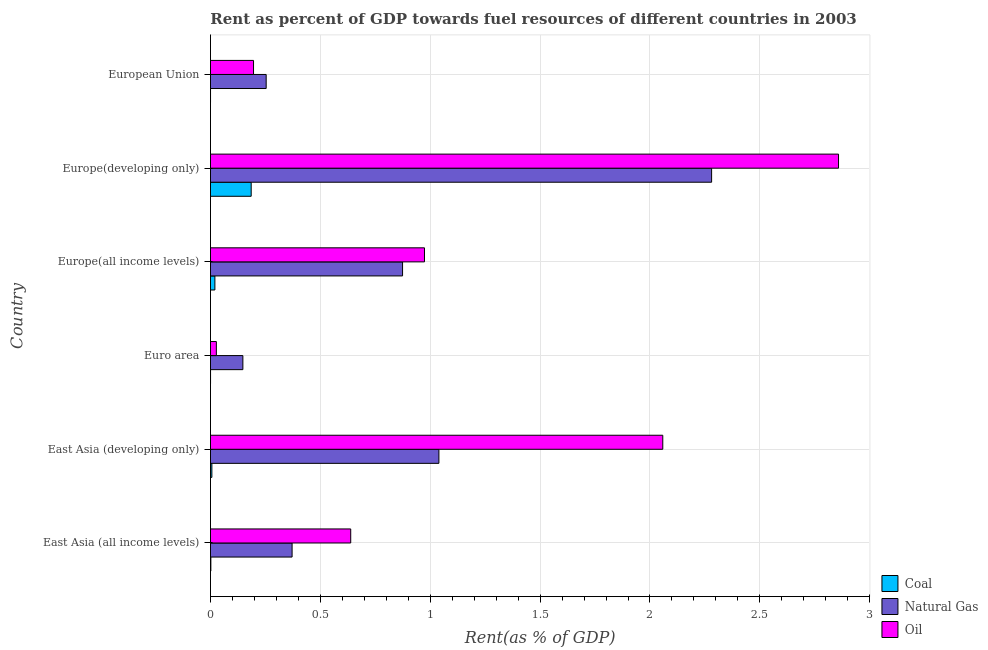How many different coloured bars are there?
Your response must be concise. 3. How many groups of bars are there?
Your answer should be very brief. 6. Are the number of bars per tick equal to the number of legend labels?
Keep it short and to the point. Yes. Are the number of bars on each tick of the Y-axis equal?
Keep it short and to the point. Yes. How many bars are there on the 2nd tick from the top?
Offer a terse response. 3. How many bars are there on the 2nd tick from the bottom?
Your answer should be very brief. 3. What is the rent towards oil in European Union?
Offer a terse response. 0.2. Across all countries, what is the maximum rent towards oil?
Your answer should be very brief. 2.86. Across all countries, what is the minimum rent towards natural gas?
Ensure brevity in your answer.  0.15. In which country was the rent towards oil maximum?
Give a very brief answer. Europe(developing only). What is the total rent towards coal in the graph?
Offer a terse response. 0.21. What is the difference between the rent towards oil in Euro area and that in European Union?
Ensure brevity in your answer.  -0.17. What is the difference between the rent towards oil in Europe(all income levels) and the rent towards natural gas in European Union?
Keep it short and to the point. 0.72. What is the average rent towards natural gas per country?
Your response must be concise. 0.83. What is the difference between the rent towards coal and rent towards natural gas in Europe(all income levels)?
Your answer should be very brief. -0.85. In how many countries, is the rent towards coal greater than 2.5 %?
Provide a succinct answer. 0. What is the ratio of the rent towards oil in East Asia (developing only) to that in Europe(all income levels)?
Make the answer very short. 2.11. Is the rent towards oil in Euro area less than that in Europe(developing only)?
Offer a very short reply. Yes. What is the difference between the highest and the second highest rent towards coal?
Your answer should be very brief. 0.17. What is the difference between the highest and the lowest rent towards natural gas?
Offer a very short reply. 2.13. What does the 2nd bar from the top in Euro area represents?
Keep it short and to the point. Natural Gas. What does the 3rd bar from the bottom in European Union represents?
Make the answer very short. Oil. Is it the case that in every country, the sum of the rent towards coal and rent towards natural gas is greater than the rent towards oil?
Keep it short and to the point. No. How many bars are there?
Keep it short and to the point. 18. How many countries are there in the graph?
Make the answer very short. 6. What is the difference between two consecutive major ticks on the X-axis?
Your response must be concise. 0.5. Does the graph contain any zero values?
Your answer should be compact. No. How many legend labels are there?
Provide a short and direct response. 3. What is the title of the graph?
Offer a terse response. Rent as percent of GDP towards fuel resources of different countries in 2003. Does "Transport equipments" appear as one of the legend labels in the graph?
Offer a terse response. No. What is the label or title of the X-axis?
Keep it short and to the point. Rent(as % of GDP). What is the Rent(as % of GDP) in Coal in East Asia (all income levels)?
Provide a succinct answer. 0. What is the Rent(as % of GDP) of Natural Gas in East Asia (all income levels)?
Offer a terse response. 0.37. What is the Rent(as % of GDP) of Oil in East Asia (all income levels)?
Provide a short and direct response. 0.64. What is the Rent(as % of GDP) of Coal in East Asia (developing only)?
Your response must be concise. 0.01. What is the Rent(as % of GDP) of Natural Gas in East Asia (developing only)?
Offer a terse response. 1.04. What is the Rent(as % of GDP) in Oil in East Asia (developing only)?
Offer a very short reply. 2.06. What is the Rent(as % of GDP) in Coal in Euro area?
Make the answer very short. 0. What is the Rent(as % of GDP) in Natural Gas in Euro area?
Your answer should be very brief. 0.15. What is the Rent(as % of GDP) of Oil in Euro area?
Give a very brief answer. 0.03. What is the Rent(as % of GDP) of Coal in Europe(all income levels)?
Offer a very short reply. 0.02. What is the Rent(as % of GDP) of Natural Gas in Europe(all income levels)?
Your answer should be very brief. 0.87. What is the Rent(as % of GDP) in Oil in Europe(all income levels)?
Offer a terse response. 0.97. What is the Rent(as % of GDP) of Coal in Europe(developing only)?
Provide a succinct answer. 0.19. What is the Rent(as % of GDP) of Natural Gas in Europe(developing only)?
Provide a short and direct response. 2.28. What is the Rent(as % of GDP) of Oil in Europe(developing only)?
Provide a succinct answer. 2.86. What is the Rent(as % of GDP) of Coal in European Union?
Keep it short and to the point. 0. What is the Rent(as % of GDP) of Natural Gas in European Union?
Offer a very short reply. 0.25. What is the Rent(as % of GDP) in Oil in European Union?
Provide a short and direct response. 0.2. Across all countries, what is the maximum Rent(as % of GDP) in Coal?
Provide a succinct answer. 0.19. Across all countries, what is the maximum Rent(as % of GDP) of Natural Gas?
Provide a short and direct response. 2.28. Across all countries, what is the maximum Rent(as % of GDP) of Oil?
Provide a succinct answer. 2.86. Across all countries, what is the minimum Rent(as % of GDP) of Coal?
Make the answer very short. 0. Across all countries, what is the minimum Rent(as % of GDP) of Natural Gas?
Your answer should be compact. 0.15. Across all countries, what is the minimum Rent(as % of GDP) of Oil?
Offer a very short reply. 0.03. What is the total Rent(as % of GDP) in Coal in the graph?
Ensure brevity in your answer.  0.21. What is the total Rent(as % of GDP) of Natural Gas in the graph?
Give a very brief answer. 4.97. What is the total Rent(as % of GDP) of Oil in the graph?
Give a very brief answer. 6.75. What is the difference between the Rent(as % of GDP) of Coal in East Asia (all income levels) and that in East Asia (developing only)?
Provide a short and direct response. -0. What is the difference between the Rent(as % of GDP) of Natural Gas in East Asia (all income levels) and that in East Asia (developing only)?
Ensure brevity in your answer.  -0.67. What is the difference between the Rent(as % of GDP) of Oil in East Asia (all income levels) and that in East Asia (developing only)?
Give a very brief answer. -1.42. What is the difference between the Rent(as % of GDP) of Coal in East Asia (all income levels) and that in Euro area?
Provide a short and direct response. 0. What is the difference between the Rent(as % of GDP) in Natural Gas in East Asia (all income levels) and that in Euro area?
Your response must be concise. 0.22. What is the difference between the Rent(as % of GDP) of Oil in East Asia (all income levels) and that in Euro area?
Provide a succinct answer. 0.61. What is the difference between the Rent(as % of GDP) in Coal in East Asia (all income levels) and that in Europe(all income levels)?
Provide a succinct answer. -0.02. What is the difference between the Rent(as % of GDP) of Natural Gas in East Asia (all income levels) and that in Europe(all income levels)?
Offer a very short reply. -0.5. What is the difference between the Rent(as % of GDP) of Oil in East Asia (all income levels) and that in Europe(all income levels)?
Your response must be concise. -0.34. What is the difference between the Rent(as % of GDP) in Coal in East Asia (all income levels) and that in Europe(developing only)?
Offer a very short reply. -0.18. What is the difference between the Rent(as % of GDP) in Natural Gas in East Asia (all income levels) and that in Europe(developing only)?
Your answer should be compact. -1.91. What is the difference between the Rent(as % of GDP) in Oil in East Asia (all income levels) and that in Europe(developing only)?
Offer a terse response. -2.22. What is the difference between the Rent(as % of GDP) of Coal in East Asia (all income levels) and that in European Union?
Keep it short and to the point. 0. What is the difference between the Rent(as % of GDP) in Natural Gas in East Asia (all income levels) and that in European Union?
Keep it short and to the point. 0.12. What is the difference between the Rent(as % of GDP) in Oil in East Asia (all income levels) and that in European Union?
Provide a succinct answer. 0.44. What is the difference between the Rent(as % of GDP) of Coal in East Asia (developing only) and that in Euro area?
Make the answer very short. 0.01. What is the difference between the Rent(as % of GDP) in Natural Gas in East Asia (developing only) and that in Euro area?
Ensure brevity in your answer.  0.89. What is the difference between the Rent(as % of GDP) in Oil in East Asia (developing only) and that in Euro area?
Ensure brevity in your answer.  2.03. What is the difference between the Rent(as % of GDP) of Coal in East Asia (developing only) and that in Europe(all income levels)?
Provide a short and direct response. -0.01. What is the difference between the Rent(as % of GDP) of Natural Gas in East Asia (developing only) and that in Europe(all income levels)?
Provide a succinct answer. 0.17. What is the difference between the Rent(as % of GDP) of Oil in East Asia (developing only) and that in Europe(all income levels)?
Keep it short and to the point. 1.08. What is the difference between the Rent(as % of GDP) in Coal in East Asia (developing only) and that in Europe(developing only)?
Offer a very short reply. -0.18. What is the difference between the Rent(as % of GDP) of Natural Gas in East Asia (developing only) and that in Europe(developing only)?
Provide a succinct answer. -1.24. What is the difference between the Rent(as % of GDP) of Oil in East Asia (developing only) and that in Europe(developing only)?
Ensure brevity in your answer.  -0.8. What is the difference between the Rent(as % of GDP) of Coal in East Asia (developing only) and that in European Union?
Give a very brief answer. 0.01. What is the difference between the Rent(as % of GDP) in Natural Gas in East Asia (developing only) and that in European Union?
Your answer should be compact. 0.79. What is the difference between the Rent(as % of GDP) in Oil in East Asia (developing only) and that in European Union?
Your response must be concise. 1.86. What is the difference between the Rent(as % of GDP) in Coal in Euro area and that in Europe(all income levels)?
Your response must be concise. -0.02. What is the difference between the Rent(as % of GDP) in Natural Gas in Euro area and that in Europe(all income levels)?
Your response must be concise. -0.73. What is the difference between the Rent(as % of GDP) in Oil in Euro area and that in Europe(all income levels)?
Make the answer very short. -0.95. What is the difference between the Rent(as % of GDP) of Coal in Euro area and that in Europe(developing only)?
Your answer should be very brief. -0.18. What is the difference between the Rent(as % of GDP) in Natural Gas in Euro area and that in Europe(developing only)?
Give a very brief answer. -2.13. What is the difference between the Rent(as % of GDP) in Oil in Euro area and that in Europe(developing only)?
Your answer should be very brief. -2.83. What is the difference between the Rent(as % of GDP) in Natural Gas in Euro area and that in European Union?
Provide a succinct answer. -0.11. What is the difference between the Rent(as % of GDP) in Oil in Euro area and that in European Union?
Offer a very short reply. -0.17. What is the difference between the Rent(as % of GDP) in Coal in Europe(all income levels) and that in Europe(developing only)?
Give a very brief answer. -0.17. What is the difference between the Rent(as % of GDP) in Natural Gas in Europe(all income levels) and that in Europe(developing only)?
Keep it short and to the point. -1.41. What is the difference between the Rent(as % of GDP) in Oil in Europe(all income levels) and that in Europe(developing only)?
Ensure brevity in your answer.  -1.88. What is the difference between the Rent(as % of GDP) in Coal in Europe(all income levels) and that in European Union?
Ensure brevity in your answer.  0.02. What is the difference between the Rent(as % of GDP) in Natural Gas in Europe(all income levels) and that in European Union?
Give a very brief answer. 0.62. What is the difference between the Rent(as % of GDP) in Oil in Europe(all income levels) and that in European Union?
Your answer should be compact. 0.78. What is the difference between the Rent(as % of GDP) in Coal in Europe(developing only) and that in European Union?
Offer a very short reply. 0.18. What is the difference between the Rent(as % of GDP) of Natural Gas in Europe(developing only) and that in European Union?
Ensure brevity in your answer.  2.03. What is the difference between the Rent(as % of GDP) in Oil in Europe(developing only) and that in European Union?
Provide a succinct answer. 2.66. What is the difference between the Rent(as % of GDP) in Coal in East Asia (all income levels) and the Rent(as % of GDP) in Natural Gas in East Asia (developing only)?
Offer a terse response. -1.04. What is the difference between the Rent(as % of GDP) in Coal in East Asia (all income levels) and the Rent(as % of GDP) in Oil in East Asia (developing only)?
Offer a very short reply. -2.06. What is the difference between the Rent(as % of GDP) in Natural Gas in East Asia (all income levels) and the Rent(as % of GDP) in Oil in East Asia (developing only)?
Your answer should be compact. -1.69. What is the difference between the Rent(as % of GDP) of Coal in East Asia (all income levels) and the Rent(as % of GDP) of Natural Gas in Euro area?
Your answer should be very brief. -0.15. What is the difference between the Rent(as % of GDP) in Coal in East Asia (all income levels) and the Rent(as % of GDP) in Oil in Euro area?
Offer a terse response. -0.03. What is the difference between the Rent(as % of GDP) in Natural Gas in East Asia (all income levels) and the Rent(as % of GDP) in Oil in Euro area?
Provide a succinct answer. 0.34. What is the difference between the Rent(as % of GDP) in Coal in East Asia (all income levels) and the Rent(as % of GDP) in Natural Gas in Europe(all income levels)?
Offer a very short reply. -0.87. What is the difference between the Rent(as % of GDP) of Coal in East Asia (all income levels) and the Rent(as % of GDP) of Oil in Europe(all income levels)?
Make the answer very short. -0.97. What is the difference between the Rent(as % of GDP) in Natural Gas in East Asia (all income levels) and the Rent(as % of GDP) in Oil in Europe(all income levels)?
Offer a terse response. -0.6. What is the difference between the Rent(as % of GDP) in Coal in East Asia (all income levels) and the Rent(as % of GDP) in Natural Gas in Europe(developing only)?
Your answer should be compact. -2.28. What is the difference between the Rent(as % of GDP) of Coal in East Asia (all income levels) and the Rent(as % of GDP) of Oil in Europe(developing only)?
Offer a terse response. -2.86. What is the difference between the Rent(as % of GDP) in Natural Gas in East Asia (all income levels) and the Rent(as % of GDP) in Oil in Europe(developing only)?
Offer a very short reply. -2.49. What is the difference between the Rent(as % of GDP) of Coal in East Asia (all income levels) and the Rent(as % of GDP) of Natural Gas in European Union?
Offer a very short reply. -0.25. What is the difference between the Rent(as % of GDP) of Coal in East Asia (all income levels) and the Rent(as % of GDP) of Oil in European Union?
Your answer should be very brief. -0.19. What is the difference between the Rent(as % of GDP) in Natural Gas in East Asia (all income levels) and the Rent(as % of GDP) in Oil in European Union?
Make the answer very short. 0.18. What is the difference between the Rent(as % of GDP) in Coal in East Asia (developing only) and the Rent(as % of GDP) in Natural Gas in Euro area?
Offer a terse response. -0.14. What is the difference between the Rent(as % of GDP) in Coal in East Asia (developing only) and the Rent(as % of GDP) in Oil in Euro area?
Your answer should be compact. -0.02. What is the difference between the Rent(as % of GDP) of Natural Gas in East Asia (developing only) and the Rent(as % of GDP) of Oil in Euro area?
Offer a terse response. 1.01. What is the difference between the Rent(as % of GDP) of Coal in East Asia (developing only) and the Rent(as % of GDP) of Natural Gas in Europe(all income levels)?
Provide a succinct answer. -0.87. What is the difference between the Rent(as % of GDP) of Coal in East Asia (developing only) and the Rent(as % of GDP) of Oil in Europe(all income levels)?
Provide a succinct answer. -0.97. What is the difference between the Rent(as % of GDP) of Natural Gas in East Asia (developing only) and the Rent(as % of GDP) of Oil in Europe(all income levels)?
Offer a terse response. 0.07. What is the difference between the Rent(as % of GDP) in Coal in East Asia (developing only) and the Rent(as % of GDP) in Natural Gas in Europe(developing only)?
Make the answer very short. -2.27. What is the difference between the Rent(as % of GDP) of Coal in East Asia (developing only) and the Rent(as % of GDP) of Oil in Europe(developing only)?
Your response must be concise. -2.85. What is the difference between the Rent(as % of GDP) in Natural Gas in East Asia (developing only) and the Rent(as % of GDP) in Oil in Europe(developing only)?
Provide a short and direct response. -1.82. What is the difference between the Rent(as % of GDP) in Coal in East Asia (developing only) and the Rent(as % of GDP) in Natural Gas in European Union?
Provide a succinct answer. -0.25. What is the difference between the Rent(as % of GDP) of Coal in East Asia (developing only) and the Rent(as % of GDP) of Oil in European Union?
Provide a short and direct response. -0.19. What is the difference between the Rent(as % of GDP) of Natural Gas in East Asia (developing only) and the Rent(as % of GDP) of Oil in European Union?
Make the answer very short. 0.84. What is the difference between the Rent(as % of GDP) in Coal in Euro area and the Rent(as % of GDP) in Natural Gas in Europe(all income levels)?
Provide a succinct answer. -0.87. What is the difference between the Rent(as % of GDP) in Coal in Euro area and the Rent(as % of GDP) in Oil in Europe(all income levels)?
Offer a terse response. -0.97. What is the difference between the Rent(as % of GDP) in Natural Gas in Euro area and the Rent(as % of GDP) in Oil in Europe(all income levels)?
Offer a very short reply. -0.83. What is the difference between the Rent(as % of GDP) of Coal in Euro area and the Rent(as % of GDP) of Natural Gas in Europe(developing only)?
Provide a short and direct response. -2.28. What is the difference between the Rent(as % of GDP) of Coal in Euro area and the Rent(as % of GDP) of Oil in Europe(developing only)?
Your answer should be compact. -2.86. What is the difference between the Rent(as % of GDP) of Natural Gas in Euro area and the Rent(as % of GDP) of Oil in Europe(developing only)?
Provide a short and direct response. -2.71. What is the difference between the Rent(as % of GDP) in Coal in Euro area and the Rent(as % of GDP) in Natural Gas in European Union?
Your response must be concise. -0.25. What is the difference between the Rent(as % of GDP) of Coal in Euro area and the Rent(as % of GDP) of Oil in European Union?
Ensure brevity in your answer.  -0.2. What is the difference between the Rent(as % of GDP) of Natural Gas in Euro area and the Rent(as % of GDP) of Oil in European Union?
Offer a terse response. -0.05. What is the difference between the Rent(as % of GDP) in Coal in Europe(all income levels) and the Rent(as % of GDP) in Natural Gas in Europe(developing only)?
Give a very brief answer. -2.26. What is the difference between the Rent(as % of GDP) in Coal in Europe(all income levels) and the Rent(as % of GDP) in Oil in Europe(developing only)?
Provide a succinct answer. -2.84. What is the difference between the Rent(as % of GDP) of Natural Gas in Europe(all income levels) and the Rent(as % of GDP) of Oil in Europe(developing only)?
Your response must be concise. -1.98. What is the difference between the Rent(as % of GDP) of Coal in Europe(all income levels) and the Rent(as % of GDP) of Natural Gas in European Union?
Your response must be concise. -0.23. What is the difference between the Rent(as % of GDP) in Coal in Europe(all income levels) and the Rent(as % of GDP) in Oil in European Union?
Keep it short and to the point. -0.18. What is the difference between the Rent(as % of GDP) of Natural Gas in Europe(all income levels) and the Rent(as % of GDP) of Oil in European Union?
Your response must be concise. 0.68. What is the difference between the Rent(as % of GDP) in Coal in Europe(developing only) and the Rent(as % of GDP) in Natural Gas in European Union?
Keep it short and to the point. -0.07. What is the difference between the Rent(as % of GDP) in Coal in Europe(developing only) and the Rent(as % of GDP) in Oil in European Union?
Your answer should be very brief. -0.01. What is the difference between the Rent(as % of GDP) in Natural Gas in Europe(developing only) and the Rent(as % of GDP) in Oil in European Union?
Your response must be concise. 2.08. What is the average Rent(as % of GDP) in Coal per country?
Give a very brief answer. 0.04. What is the average Rent(as % of GDP) of Natural Gas per country?
Provide a succinct answer. 0.83. What is the average Rent(as % of GDP) in Oil per country?
Make the answer very short. 1.13. What is the difference between the Rent(as % of GDP) of Coal and Rent(as % of GDP) of Natural Gas in East Asia (all income levels)?
Your answer should be compact. -0.37. What is the difference between the Rent(as % of GDP) of Coal and Rent(as % of GDP) of Oil in East Asia (all income levels)?
Give a very brief answer. -0.64. What is the difference between the Rent(as % of GDP) in Natural Gas and Rent(as % of GDP) in Oil in East Asia (all income levels)?
Provide a short and direct response. -0.27. What is the difference between the Rent(as % of GDP) in Coal and Rent(as % of GDP) in Natural Gas in East Asia (developing only)?
Your answer should be very brief. -1.03. What is the difference between the Rent(as % of GDP) of Coal and Rent(as % of GDP) of Oil in East Asia (developing only)?
Offer a very short reply. -2.05. What is the difference between the Rent(as % of GDP) in Natural Gas and Rent(as % of GDP) in Oil in East Asia (developing only)?
Make the answer very short. -1.02. What is the difference between the Rent(as % of GDP) in Coal and Rent(as % of GDP) in Natural Gas in Euro area?
Make the answer very short. -0.15. What is the difference between the Rent(as % of GDP) in Coal and Rent(as % of GDP) in Oil in Euro area?
Make the answer very short. -0.03. What is the difference between the Rent(as % of GDP) of Natural Gas and Rent(as % of GDP) of Oil in Euro area?
Your answer should be very brief. 0.12. What is the difference between the Rent(as % of GDP) in Coal and Rent(as % of GDP) in Natural Gas in Europe(all income levels)?
Give a very brief answer. -0.85. What is the difference between the Rent(as % of GDP) of Coal and Rent(as % of GDP) of Oil in Europe(all income levels)?
Make the answer very short. -0.95. What is the difference between the Rent(as % of GDP) of Natural Gas and Rent(as % of GDP) of Oil in Europe(all income levels)?
Make the answer very short. -0.1. What is the difference between the Rent(as % of GDP) of Coal and Rent(as % of GDP) of Natural Gas in Europe(developing only)?
Offer a terse response. -2.1. What is the difference between the Rent(as % of GDP) in Coal and Rent(as % of GDP) in Oil in Europe(developing only)?
Ensure brevity in your answer.  -2.67. What is the difference between the Rent(as % of GDP) of Natural Gas and Rent(as % of GDP) of Oil in Europe(developing only)?
Keep it short and to the point. -0.58. What is the difference between the Rent(as % of GDP) of Coal and Rent(as % of GDP) of Natural Gas in European Union?
Your answer should be compact. -0.25. What is the difference between the Rent(as % of GDP) in Coal and Rent(as % of GDP) in Oil in European Union?
Make the answer very short. -0.2. What is the difference between the Rent(as % of GDP) of Natural Gas and Rent(as % of GDP) of Oil in European Union?
Your answer should be very brief. 0.06. What is the ratio of the Rent(as % of GDP) in Coal in East Asia (all income levels) to that in East Asia (developing only)?
Your answer should be very brief. 0.27. What is the ratio of the Rent(as % of GDP) in Natural Gas in East Asia (all income levels) to that in East Asia (developing only)?
Your answer should be very brief. 0.36. What is the ratio of the Rent(as % of GDP) of Oil in East Asia (all income levels) to that in East Asia (developing only)?
Offer a terse response. 0.31. What is the ratio of the Rent(as % of GDP) in Coal in East Asia (all income levels) to that in Euro area?
Ensure brevity in your answer.  4.9. What is the ratio of the Rent(as % of GDP) of Natural Gas in East Asia (all income levels) to that in Euro area?
Keep it short and to the point. 2.52. What is the ratio of the Rent(as % of GDP) in Oil in East Asia (all income levels) to that in Euro area?
Provide a succinct answer. 23.8. What is the ratio of the Rent(as % of GDP) in Coal in East Asia (all income levels) to that in Europe(all income levels)?
Make the answer very short. 0.09. What is the ratio of the Rent(as % of GDP) of Natural Gas in East Asia (all income levels) to that in Europe(all income levels)?
Give a very brief answer. 0.42. What is the ratio of the Rent(as % of GDP) in Oil in East Asia (all income levels) to that in Europe(all income levels)?
Provide a short and direct response. 0.66. What is the ratio of the Rent(as % of GDP) in Coal in East Asia (all income levels) to that in Europe(developing only)?
Ensure brevity in your answer.  0.01. What is the ratio of the Rent(as % of GDP) of Natural Gas in East Asia (all income levels) to that in Europe(developing only)?
Offer a terse response. 0.16. What is the ratio of the Rent(as % of GDP) in Oil in East Asia (all income levels) to that in Europe(developing only)?
Provide a succinct answer. 0.22. What is the ratio of the Rent(as % of GDP) in Coal in East Asia (all income levels) to that in European Union?
Give a very brief answer. 6.57. What is the ratio of the Rent(as % of GDP) of Natural Gas in East Asia (all income levels) to that in European Union?
Provide a succinct answer. 1.47. What is the ratio of the Rent(as % of GDP) of Oil in East Asia (all income levels) to that in European Union?
Provide a succinct answer. 3.26. What is the ratio of the Rent(as % of GDP) in Coal in East Asia (developing only) to that in Euro area?
Provide a short and direct response. 18.02. What is the ratio of the Rent(as % of GDP) in Natural Gas in East Asia (developing only) to that in Euro area?
Offer a very short reply. 7.05. What is the ratio of the Rent(as % of GDP) in Oil in East Asia (developing only) to that in Euro area?
Provide a succinct answer. 76.74. What is the ratio of the Rent(as % of GDP) of Coal in East Asia (developing only) to that in Europe(all income levels)?
Ensure brevity in your answer.  0.32. What is the ratio of the Rent(as % of GDP) in Natural Gas in East Asia (developing only) to that in Europe(all income levels)?
Offer a very short reply. 1.19. What is the ratio of the Rent(as % of GDP) of Oil in East Asia (developing only) to that in Europe(all income levels)?
Make the answer very short. 2.11. What is the ratio of the Rent(as % of GDP) in Coal in East Asia (developing only) to that in Europe(developing only)?
Offer a very short reply. 0.03. What is the ratio of the Rent(as % of GDP) of Natural Gas in East Asia (developing only) to that in Europe(developing only)?
Provide a short and direct response. 0.46. What is the ratio of the Rent(as % of GDP) in Oil in East Asia (developing only) to that in Europe(developing only)?
Give a very brief answer. 0.72. What is the ratio of the Rent(as % of GDP) in Coal in East Asia (developing only) to that in European Union?
Offer a very short reply. 24.15. What is the ratio of the Rent(as % of GDP) of Natural Gas in East Asia (developing only) to that in European Union?
Provide a succinct answer. 4.1. What is the ratio of the Rent(as % of GDP) of Oil in East Asia (developing only) to that in European Union?
Your response must be concise. 10.5. What is the ratio of the Rent(as % of GDP) of Coal in Euro area to that in Europe(all income levels)?
Your answer should be very brief. 0.02. What is the ratio of the Rent(as % of GDP) in Natural Gas in Euro area to that in Europe(all income levels)?
Ensure brevity in your answer.  0.17. What is the ratio of the Rent(as % of GDP) in Oil in Euro area to that in Europe(all income levels)?
Your response must be concise. 0.03. What is the ratio of the Rent(as % of GDP) in Coal in Euro area to that in Europe(developing only)?
Give a very brief answer. 0. What is the ratio of the Rent(as % of GDP) of Natural Gas in Euro area to that in Europe(developing only)?
Your response must be concise. 0.06. What is the ratio of the Rent(as % of GDP) in Oil in Euro area to that in Europe(developing only)?
Make the answer very short. 0.01. What is the ratio of the Rent(as % of GDP) in Coal in Euro area to that in European Union?
Your answer should be compact. 1.34. What is the ratio of the Rent(as % of GDP) of Natural Gas in Euro area to that in European Union?
Your response must be concise. 0.58. What is the ratio of the Rent(as % of GDP) in Oil in Euro area to that in European Union?
Ensure brevity in your answer.  0.14. What is the ratio of the Rent(as % of GDP) of Coal in Europe(all income levels) to that in Europe(developing only)?
Ensure brevity in your answer.  0.11. What is the ratio of the Rent(as % of GDP) in Natural Gas in Europe(all income levels) to that in Europe(developing only)?
Offer a terse response. 0.38. What is the ratio of the Rent(as % of GDP) in Oil in Europe(all income levels) to that in Europe(developing only)?
Provide a short and direct response. 0.34. What is the ratio of the Rent(as % of GDP) in Coal in Europe(all income levels) to that in European Union?
Provide a short and direct response. 75.59. What is the ratio of the Rent(as % of GDP) of Natural Gas in Europe(all income levels) to that in European Union?
Ensure brevity in your answer.  3.45. What is the ratio of the Rent(as % of GDP) of Oil in Europe(all income levels) to that in European Union?
Offer a terse response. 4.97. What is the ratio of the Rent(as % of GDP) in Coal in Europe(developing only) to that in European Union?
Offer a very short reply. 697.51. What is the ratio of the Rent(as % of GDP) in Natural Gas in Europe(developing only) to that in European Union?
Your response must be concise. 9. What is the ratio of the Rent(as % of GDP) in Oil in Europe(developing only) to that in European Union?
Your response must be concise. 14.59. What is the difference between the highest and the second highest Rent(as % of GDP) of Coal?
Ensure brevity in your answer.  0.17. What is the difference between the highest and the second highest Rent(as % of GDP) of Natural Gas?
Offer a terse response. 1.24. What is the difference between the highest and the second highest Rent(as % of GDP) in Oil?
Keep it short and to the point. 0.8. What is the difference between the highest and the lowest Rent(as % of GDP) of Coal?
Provide a succinct answer. 0.18. What is the difference between the highest and the lowest Rent(as % of GDP) of Natural Gas?
Your answer should be compact. 2.13. What is the difference between the highest and the lowest Rent(as % of GDP) in Oil?
Make the answer very short. 2.83. 